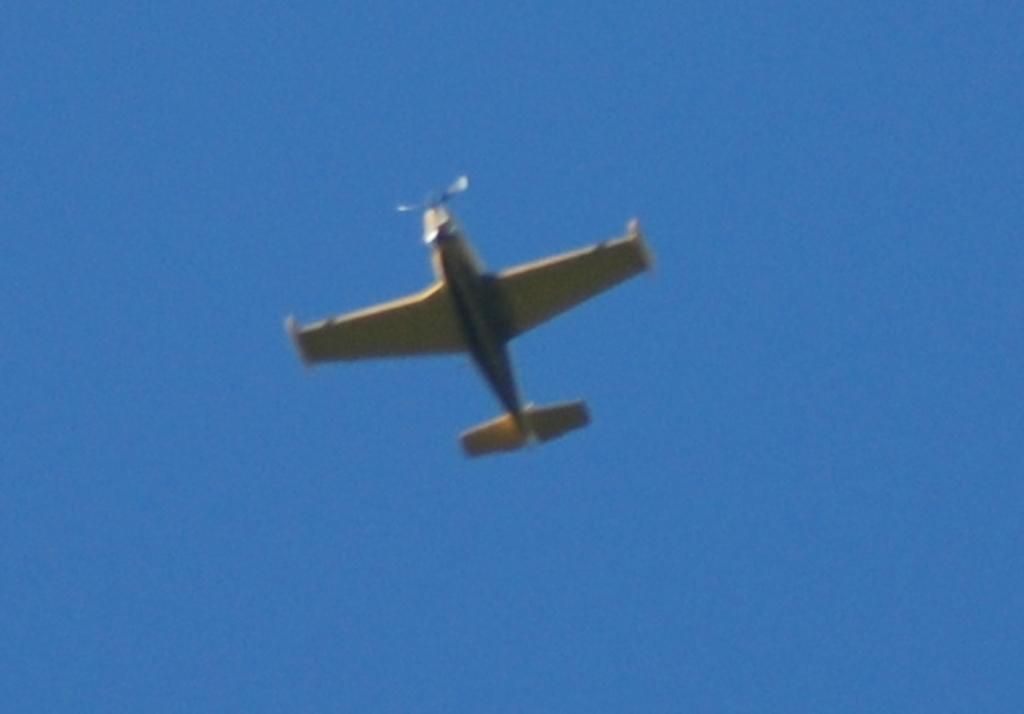What is the main subject of the image? The main subject of the image is an airplane. Where is the airplane located in the image? The airplane is in the sky. What type of bun is being used to transport the airplane in the image? There is no bun or transportation method for the airplane present in the image; the airplane is simply flying in the sky. 